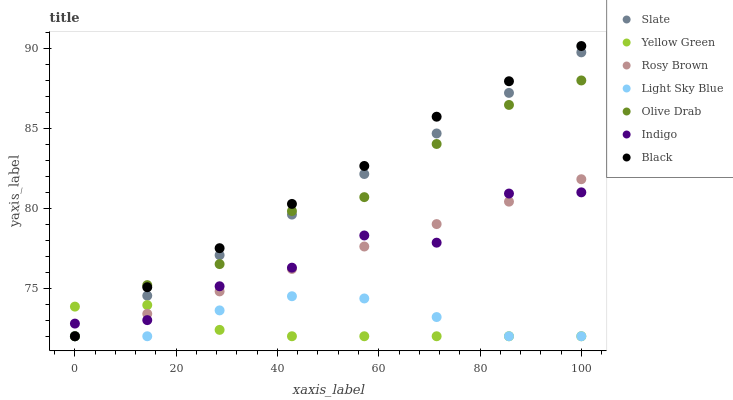Does Yellow Green have the minimum area under the curve?
Answer yes or no. Yes. Does Black have the maximum area under the curve?
Answer yes or no. Yes. Does Slate have the minimum area under the curve?
Answer yes or no. No. Does Slate have the maximum area under the curve?
Answer yes or no. No. Is Slate the smoothest?
Answer yes or no. Yes. Is Indigo the roughest?
Answer yes or no. Yes. Is Yellow Green the smoothest?
Answer yes or no. No. Is Yellow Green the roughest?
Answer yes or no. No. Does Yellow Green have the lowest value?
Answer yes or no. Yes. Does Black have the highest value?
Answer yes or no. Yes. Does Slate have the highest value?
Answer yes or no. No. Is Light Sky Blue less than Indigo?
Answer yes or no. Yes. Is Indigo greater than Light Sky Blue?
Answer yes or no. Yes. Does Indigo intersect Yellow Green?
Answer yes or no. Yes. Is Indigo less than Yellow Green?
Answer yes or no. No. Is Indigo greater than Yellow Green?
Answer yes or no. No. Does Light Sky Blue intersect Indigo?
Answer yes or no. No. 